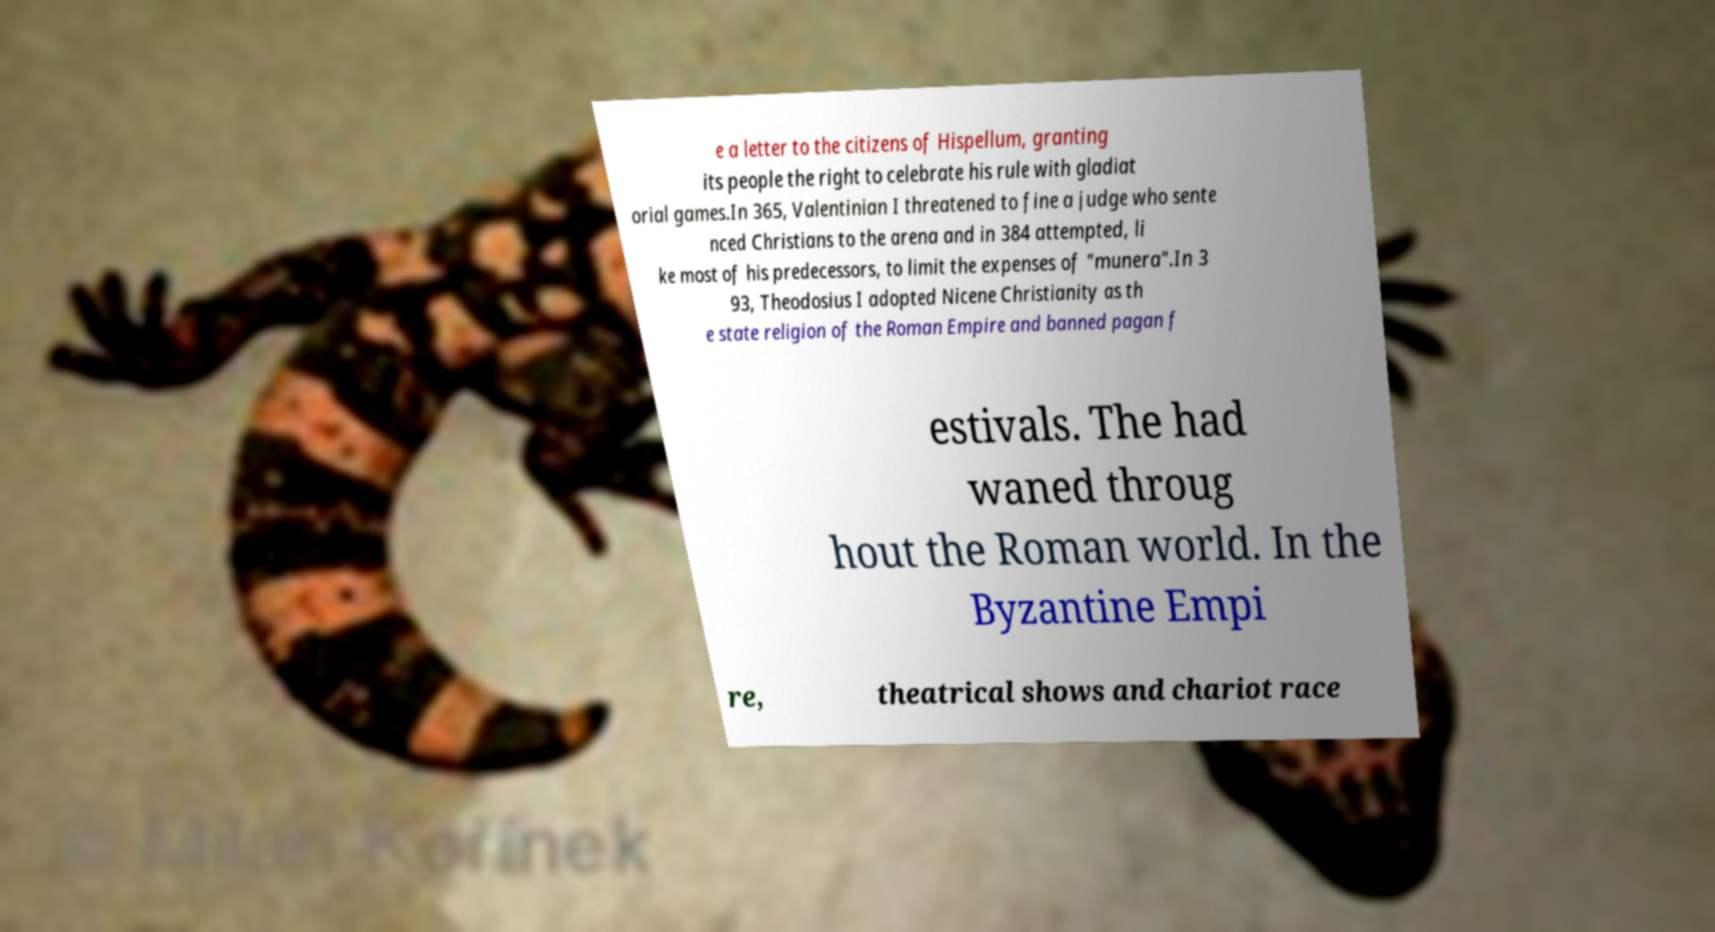I need the written content from this picture converted into text. Can you do that? e a letter to the citizens of Hispellum, granting its people the right to celebrate his rule with gladiat orial games.In 365, Valentinian I threatened to fine a judge who sente nced Christians to the arena and in 384 attempted, li ke most of his predecessors, to limit the expenses of "munera".In 3 93, Theodosius I adopted Nicene Christianity as th e state religion of the Roman Empire and banned pagan f estivals. The had waned throug hout the Roman world. In the Byzantine Empi re, theatrical shows and chariot race 